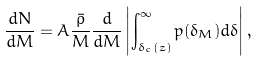Convert formula to latex. <formula><loc_0><loc_0><loc_500><loc_500>\frac { d N } { d M } = A \frac { \bar { \rho } } { M } \frac { d } { d M } \left | \int _ { \delta _ { c } ( z ) } ^ { \infty } p ( \delta _ { M } ) d \delta \right | ,</formula> 